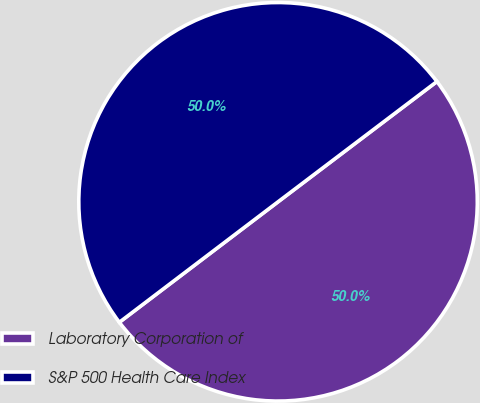Convert chart to OTSL. <chart><loc_0><loc_0><loc_500><loc_500><pie_chart><fcel>Laboratory Corporation of<fcel>S&P 500 Health Care Index<nl><fcel>49.98%<fcel>50.02%<nl></chart> 